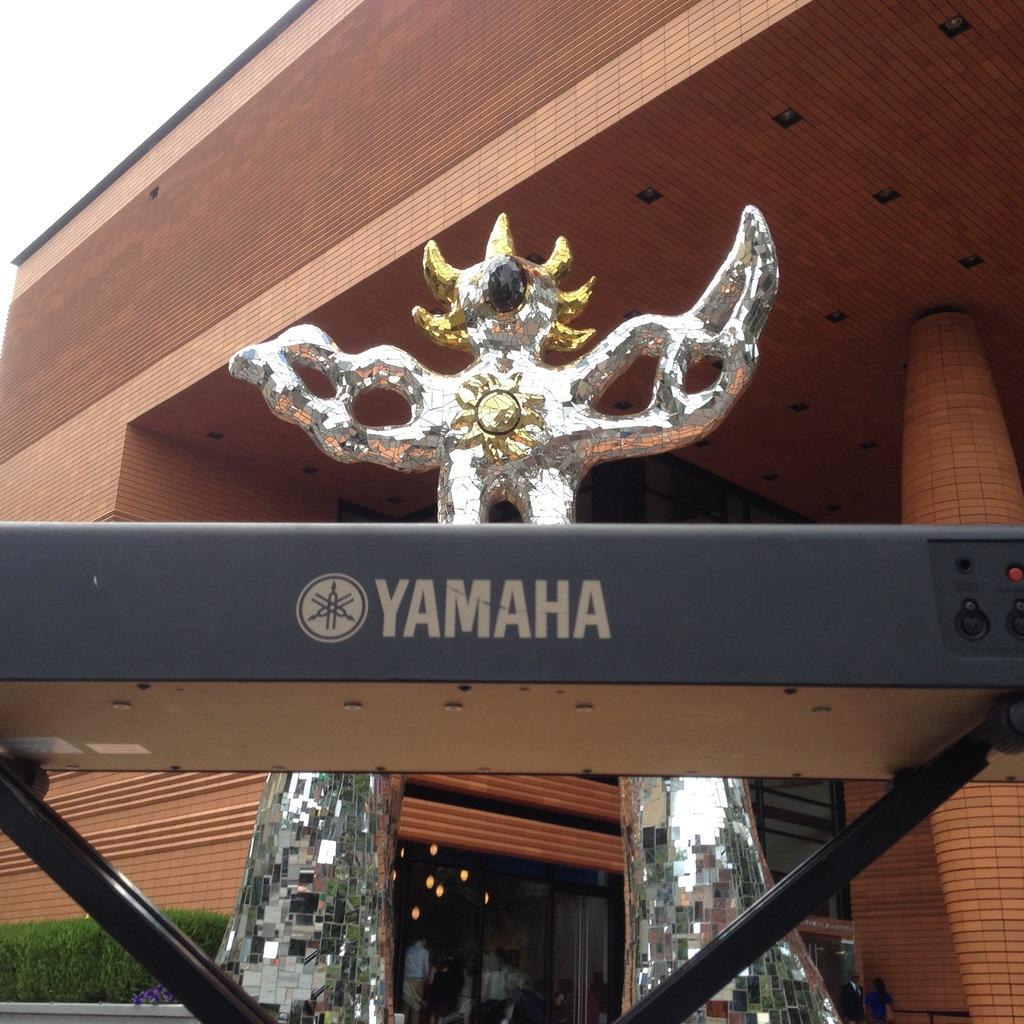What can be seen in the foreground of the image? In the foreground of the image, there is a fence, a sculpture, plants, and a group of people on the road. What type of structure is present in the image? There is a building in the image. What is visible in the top left corner of the image? The sky is visible in the top left corner of the image. When was the image taken? The image was taken during the day. What type of wheel is being used by the people in the image? There is no wheel present in the image; the people are on a road, but no wheeled vehicles or objects are visible. How many spoons are being used by the plants in the image? There are no spoons present in the image, and plants do not use spoons. 